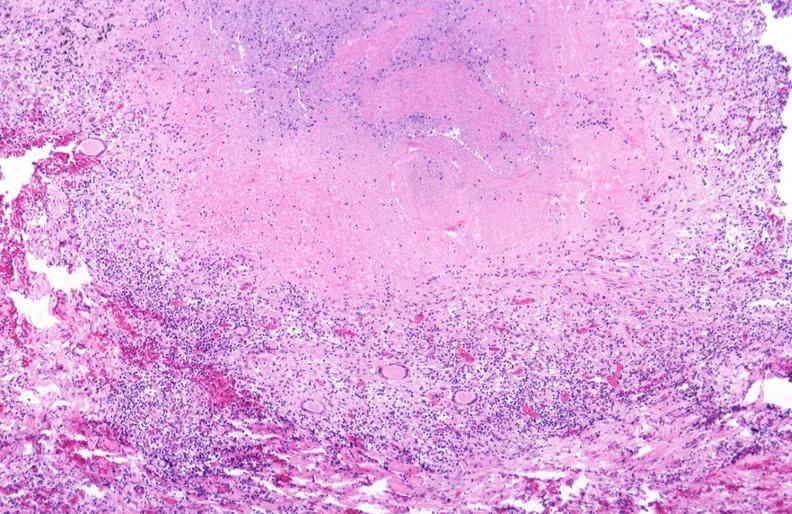does this image show lung, mycobacterium tuberculosis, granulomas and giant cells?
Answer the question using a single word or phrase. Yes 